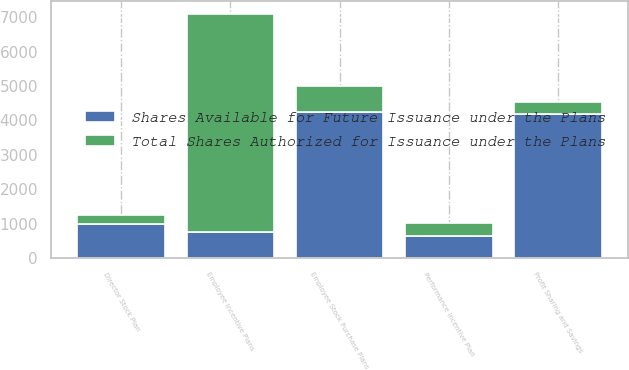Convert chart to OTSL. <chart><loc_0><loc_0><loc_500><loc_500><stacked_bar_chart><ecel><fcel>Employee Incentive Plans<fcel>Director Stock Plan<fcel>Performance Incentive Plan<fcel>Employee Stock Purchase Plans<fcel>Profit Sharing and Savings<nl><fcel>Shares Available for Future Issuance under the Plans<fcel>764<fcel>1000<fcel>650<fcel>4250<fcel>4200<nl><fcel>Total Shares Authorized for Issuance under the Plans<fcel>6334<fcel>263<fcel>383<fcel>764<fcel>349<nl></chart> 